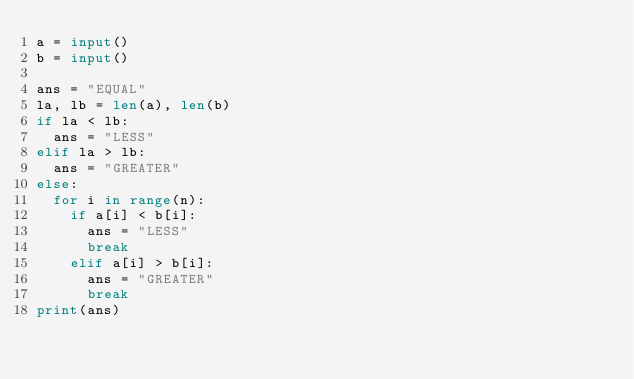<code> <loc_0><loc_0><loc_500><loc_500><_Python_>a = input()
b = input()

ans = "EQUAL"
la, lb = len(a), len(b)
if la < lb:
  ans = "LESS"
elif la > lb:
  ans = "GREATER"
else:
  for i in range(n):
    if a[i] < b[i]:
      ans = "LESS"
      break
  	elif a[i] > b[i]:
      ans = "GREATER"
      break
print(ans)</code> 